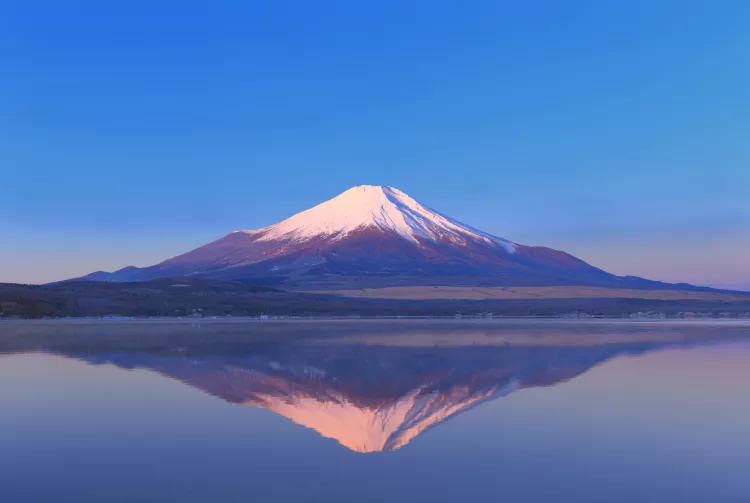What time of day does this photo seem to capture and why is that significant? This photo captures the early hours of the morning, evident from the soft pink hues on Mount Fuji's snow-covered peak and the clear, light sky. The morning light is significant as it highlights the mountain's majestic presence and creates a peaceful, reflective atmosphere, allowing for a clear and vibrant reflection on the water's surface. 